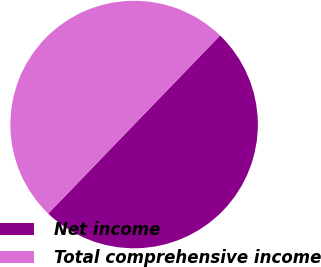Convert chart. <chart><loc_0><loc_0><loc_500><loc_500><pie_chart><fcel>Net income<fcel>Total comprehensive income<nl><fcel>50.0%<fcel>50.0%<nl></chart> 